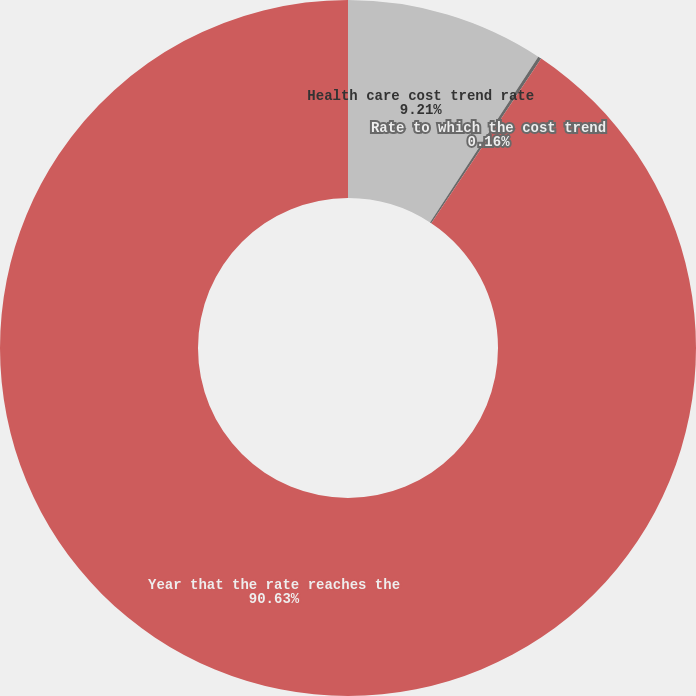Convert chart to OTSL. <chart><loc_0><loc_0><loc_500><loc_500><pie_chart><fcel>Health care cost trend rate<fcel>Rate to which the cost trend<fcel>Year that the rate reaches the<nl><fcel>9.21%<fcel>0.16%<fcel>90.64%<nl></chart> 